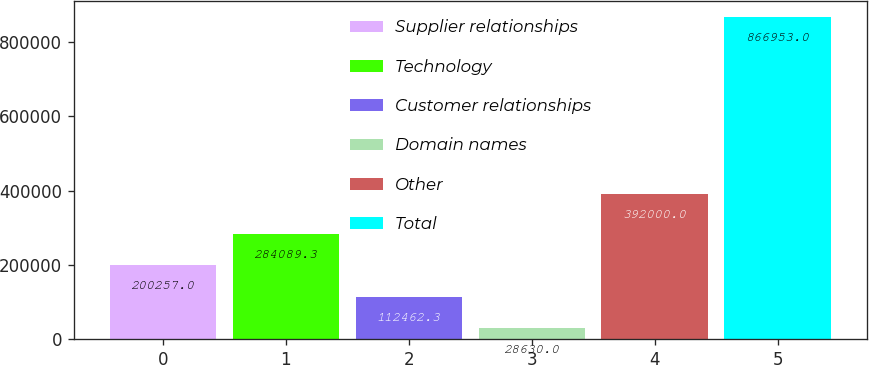Convert chart to OTSL. <chart><loc_0><loc_0><loc_500><loc_500><bar_chart><fcel>Supplier relationships<fcel>Technology<fcel>Customer relationships<fcel>Domain names<fcel>Other<fcel>Total<nl><fcel>200257<fcel>284089<fcel>112462<fcel>28630<fcel>392000<fcel>866953<nl></chart> 